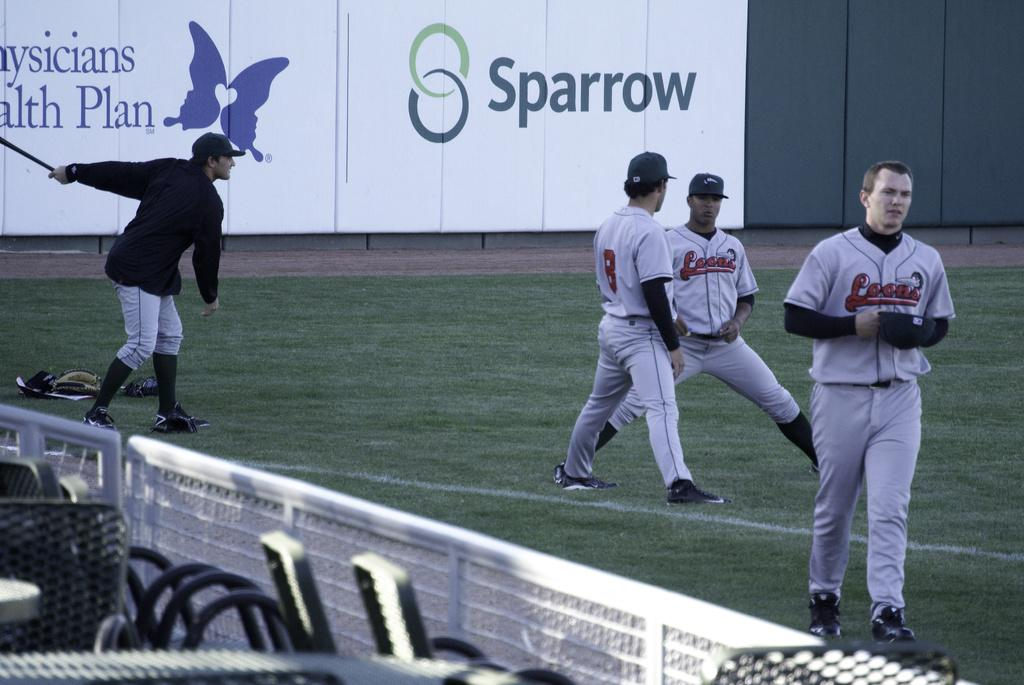Provide a one-sentence caption for the provided image. An advertisement for Sparrow behind a couple of baseball players. 